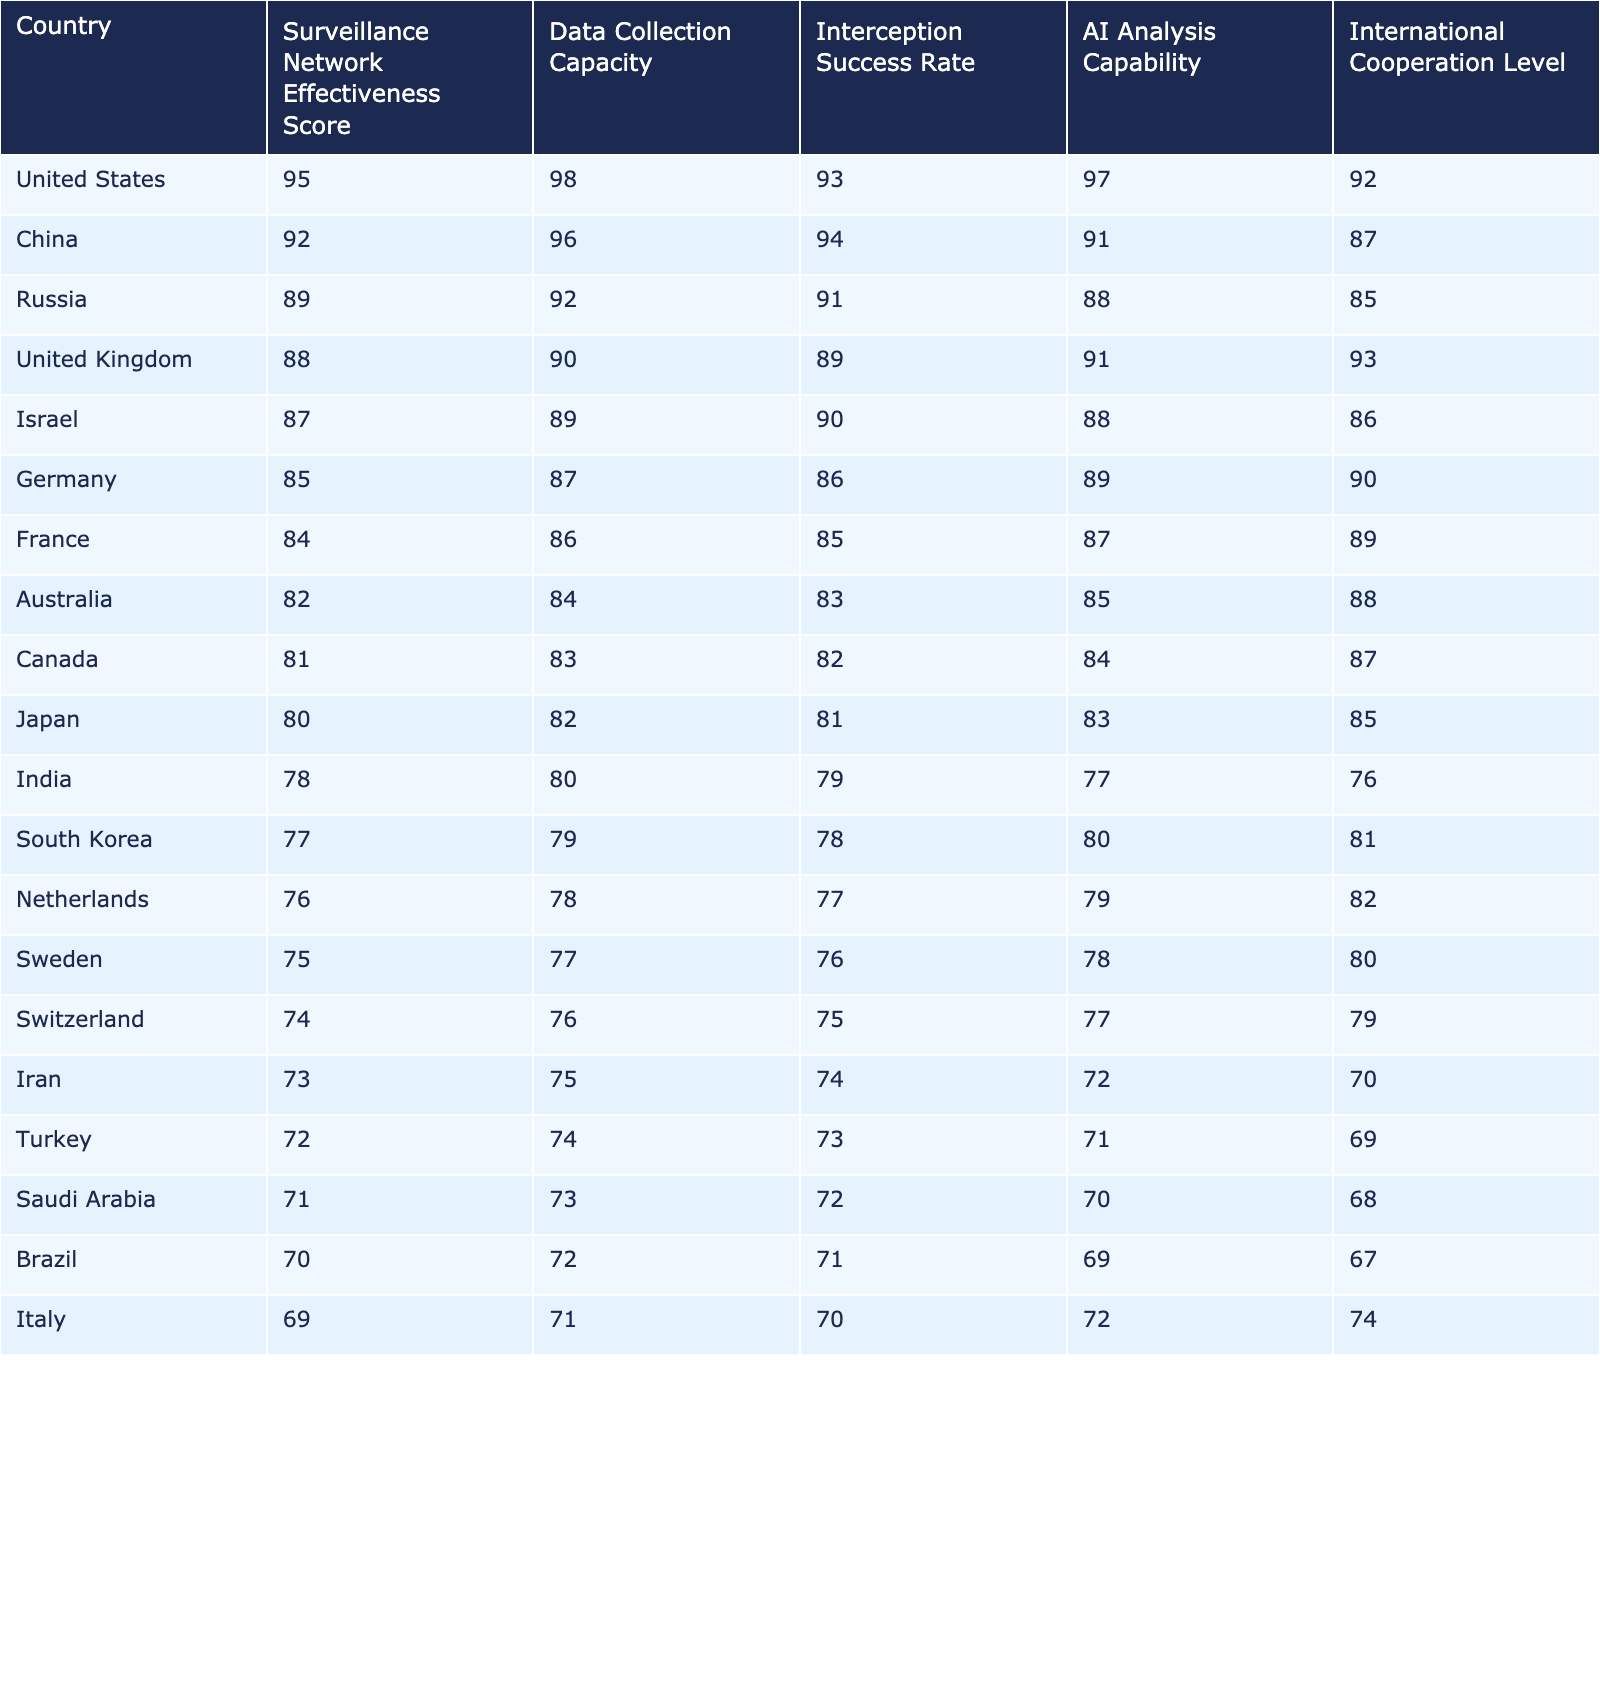What is the Surveillance Network Effectiveness Score of the United States? According to the table, the Surveillance Network Effectiveness Score for the United States is clearly listed as 95.
Answer: 95 Which country has the highest Interception Success Rate? By examining the Interception Success Rate column, the United States has the highest rate with a score of 93.
Answer: United States What is the average AI Analysis Capability score of the top three countries? The top three countries in the list (United States, China, and Russia) have AI Analysis Capability scores of 97, 91, and 88, respectively. Adding these gives 97 + 91 + 88 = 276. Dividing by 3 (to find the average) gives us 276/3 = 92.
Answer: 92 Is the effectiveness score of Germany greater than that of Canada? Germany has a score of 85, while Canada has a score of 81. Since 85 > 81, the statement is true.
Answer: Yes What country has the greatest difference in Data Collection Capacity compared to Saudi Arabia? Saudi Arabia has a Data Collection Capacity score of 73. The country with the highest score is the United States at 98. The difference is 98 - 73 = 25, which is the largest gap shown in the table.
Answer: United States What is the Median Surveillance Network Effectiveness Score of the countries listed? To find the median, we must align the scores in order: 71, 72, 73, 74, 75, 76, 77, 78, 80, 81, 82, 84, 85, 87, 88, 89, 89, 92, 95. There are 20 values, and the median is the average of the 10th and 11th values (82 and 84), which equals (82 + 84)/2 = 83.
Answer: 83 Which country has the least International Cooperation Level among those listed? From the International Cooperation Level column, Saudi Arabia scored the lowest at 68.
Answer: Saudi Arabia How do the Data Collection Capacity scores of the United States and Russia compare? The United States has a Data Collection Capacity score of 98, while Russia has 92. The difference is 98 - 92 = 6, indicating the U.S. scores higher.
Answer: United States has a higher score Which country is ranked fifth in terms of Surveillance Network Effectiveness Score? By reviewing the ordered scores, Israel is fifth with a score of 87.
Answer: Israel Are the Interception Success Rates of Iran and Turkey equal? The Interception Success Rate for Iran is 74 and for Turkey, it’s 73. They are not equal, as 74 ≠ 73.
Answer: No Identify the country with the lowest AI Analysis Capability score. When looking at the AI Analysis Capability column, Iran has the lowest score of 72.
Answer: Iran 